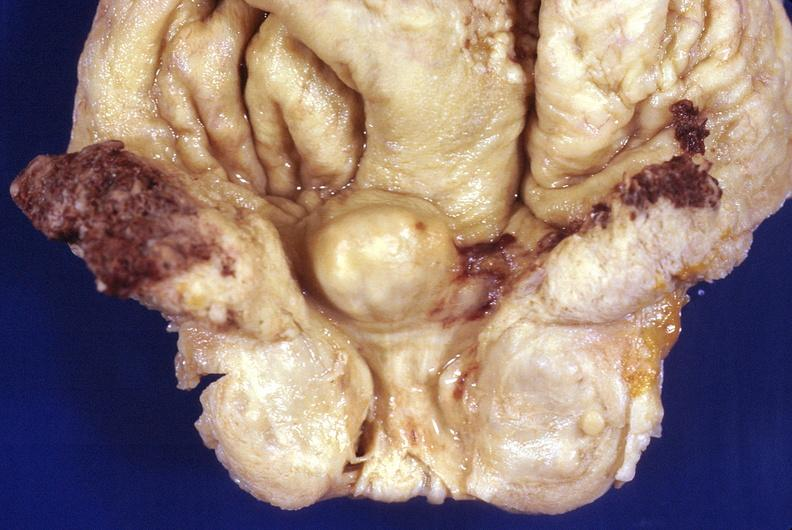what does this image show?
Answer the question using a single word or phrase. Prostatic hyperplasia 